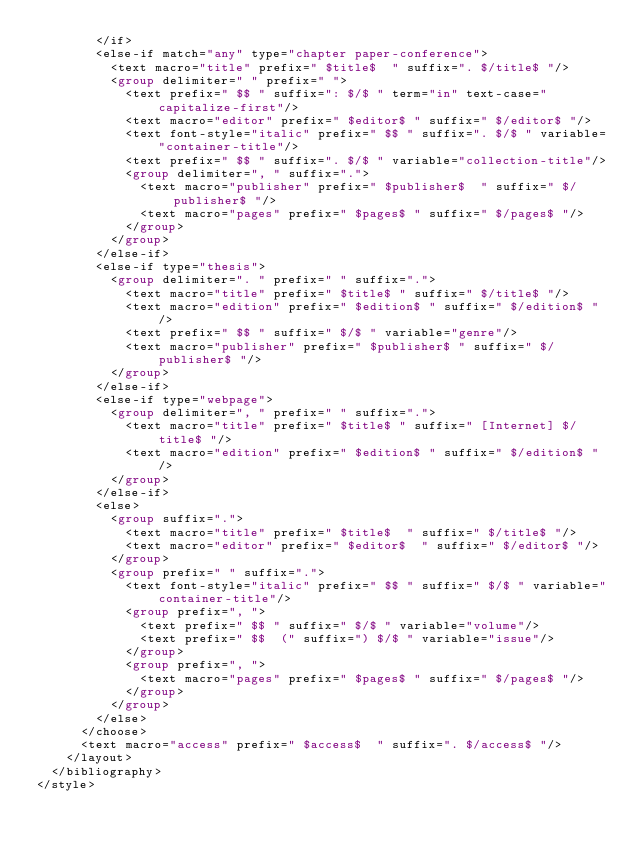Convert code to text. <code><loc_0><loc_0><loc_500><loc_500><_XML_>        </if>
        <else-if match="any" type="chapter paper-conference">
          <text macro="title" prefix=" $title$  " suffix=". $/title$ "/>
          <group delimiter=" " prefix=" ">
            <text prefix=" $$ " suffix=": $/$ " term="in" text-case="capitalize-first"/>
            <text macro="editor" prefix=" $editor$ " suffix=" $/editor$ "/>
            <text font-style="italic" prefix=" $$ " suffix=". $/$ " variable="container-title"/>
            <text prefix=" $$ " suffix=". $/$ " variable="collection-title"/>
            <group delimiter=", " suffix=".">
              <text macro="publisher" prefix=" $publisher$  " suffix=" $/publisher$ "/>
              <text macro="pages" prefix=" $pages$ " suffix=" $/pages$ "/>
            </group>
          </group>
        </else-if>
        <else-if type="thesis">
          <group delimiter=". " prefix=" " suffix=".">
            <text macro="title" prefix=" $title$ " suffix=" $/title$ "/>
            <text macro="edition" prefix=" $edition$ " suffix=" $/edition$ "/>
            <text prefix=" $$ " suffix=" $/$ " variable="genre"/>
            <text macro="publisher" prefix=" $publisher$ " suffix=" $/publisher$ "/>
          </group>
        </else-if>
        <else-if type="webpage">
          <group delimiter=", " prefix=" " suffix=".">
            <text macro="title" prefix=" $title$ " suffix=" [Internet] $/title$ "/>
            <text macro="edition" prefix=" $edition$ " suffix=" $/edition$ "/>
          </group>
        </else-if>
        <else>
          <group suffix=".">
            <text macro="title" prefix=" $title$  " suffix=" $/title$ "/>
            <text macro="editor" prefix=" $editor$  " suffix=" $/editor$ "/>
          </group>
          <group prefix=" " suffix=".">
            <text font-style="italic" prefix=" $$ " suffix=" $/$ " variable="container-title"/>
            <group prefix=", ">
              <text prefix=" $$ " suffix=" $/$ " variable="volume"/>
              <text prefix=" $$  (" suffix=") $/$ " variable="issue"/>
            </group>
            <group prefix=", ">
              <text macro="pages" prefix=" $pages$ " suffix=" $/pages$ "/>
            </group>
          </group>
        </else>
      </choose>
      <text macro="access" prefix=" $access$  " suffix=". $/access$ "/>
    </layout>
  </bibliography>
</style></code> 